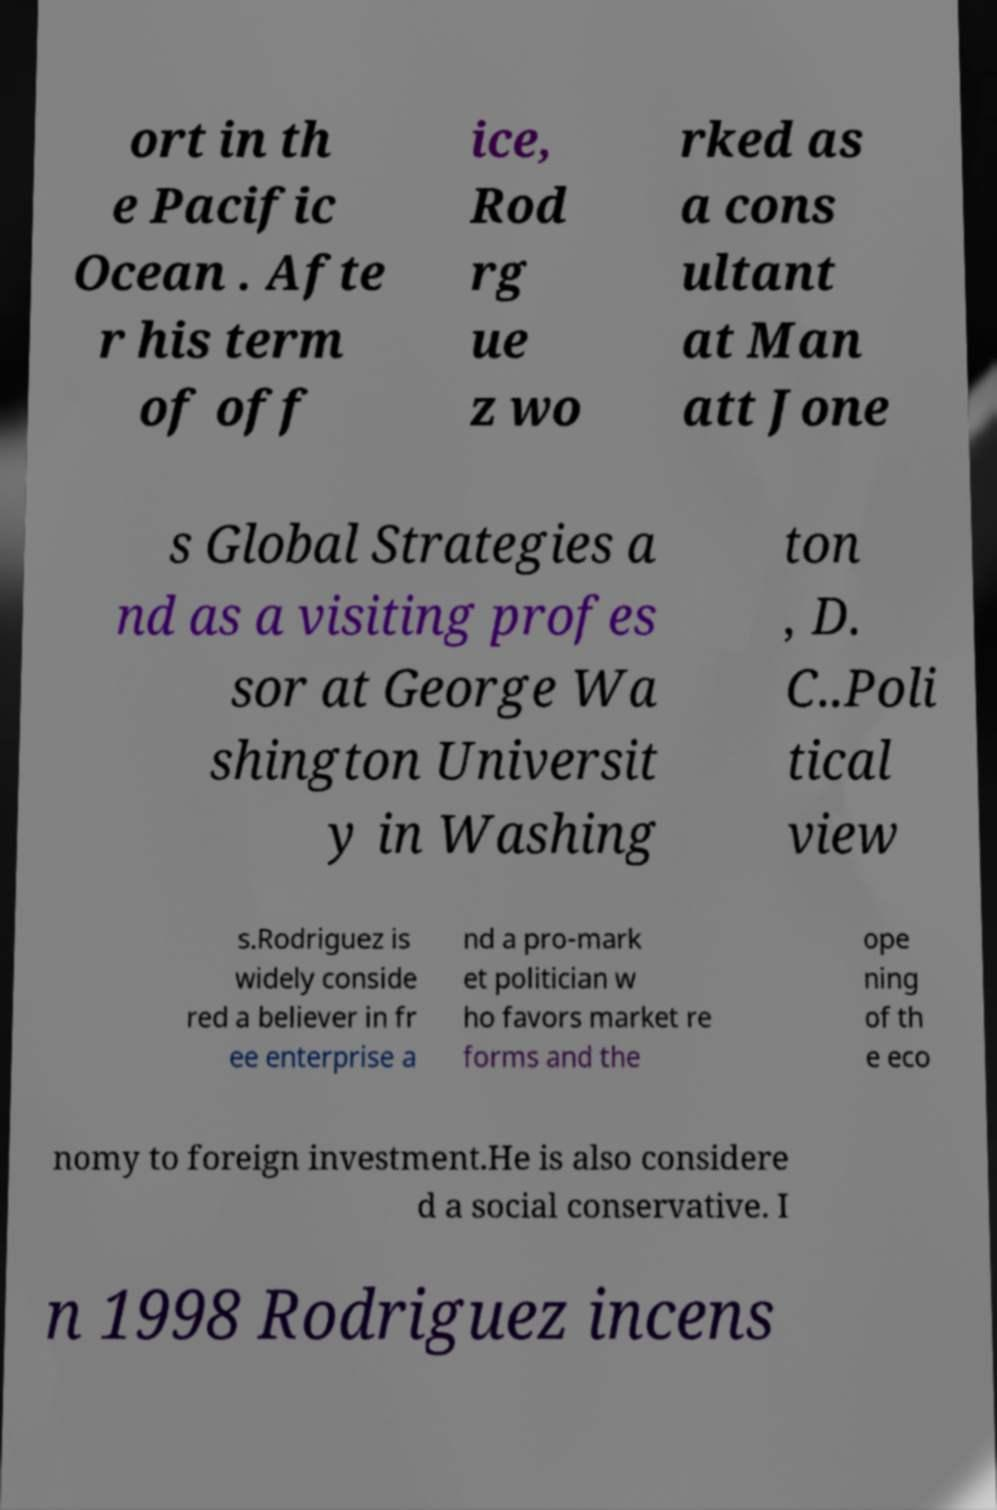Can you accurately transcribe the text from the provided image for me? ort in th e Pacific Ocean . Afte r his term of off ice, Rod rg ue z wo rked as a cons ultant at Man att Jone s Global Strategies a nd as a visiting profes sor at George Wa shington Universit y in Washing ton , D. C..Poli tical view s.Rodriguez is widely conside red a believer in fr ee enterprise a nd a pro-mark et politician w ho favors market re forms and the ope ning of th e eco nomy to foreign investment.He is also considere d a social conservative. I n 1998 Rodriguez incens 